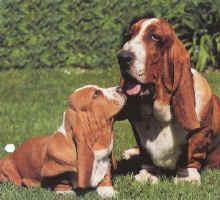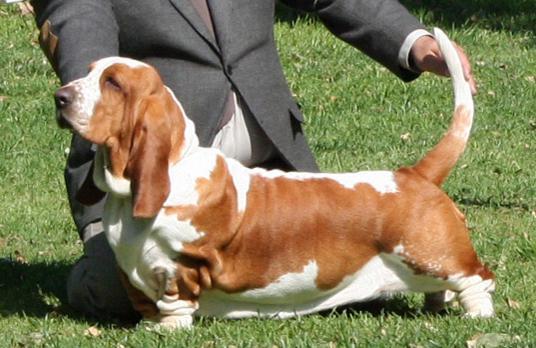The first image is the image on the left, the second image is the image on the right. For the images shown, is this caption "A sitting basset hound is interacting with one smaller basset hound on the grass." true? Answer yes or no. Yes. The first image is the image on the left, the second image is the image on the right. Assess this claim about the two images: "A single dog is standing int he grass in one of the images.". Correct or not? Answer yes or no. Yes. 